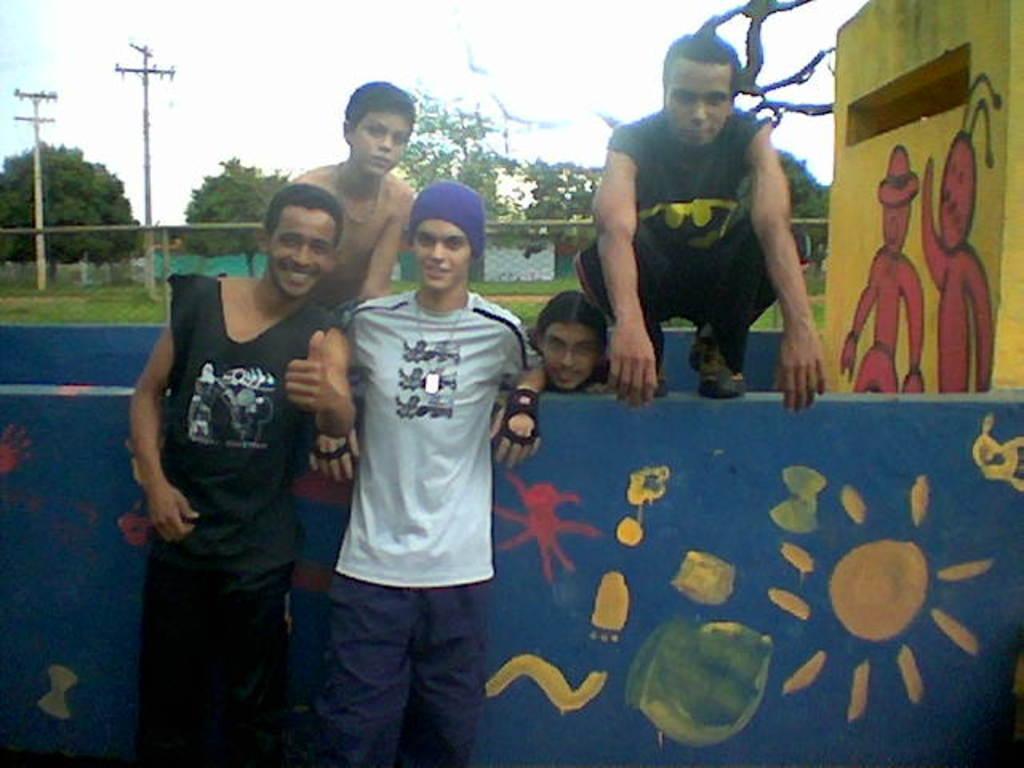Can you describe this image briefly? In this image we can see people standing on the ground and some are sitting on the wall. In the background we can see trees, electric poles, sportsnet, walls and sky. 